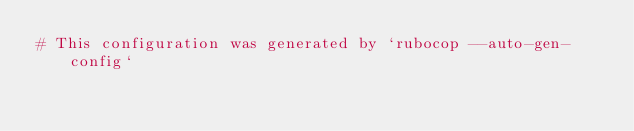Convert code to text. <code><loc_0><loc_0><loc_500><loc_500><_YAML_># This configuration was generated by `rubocop --auto-gen-config`</code> 